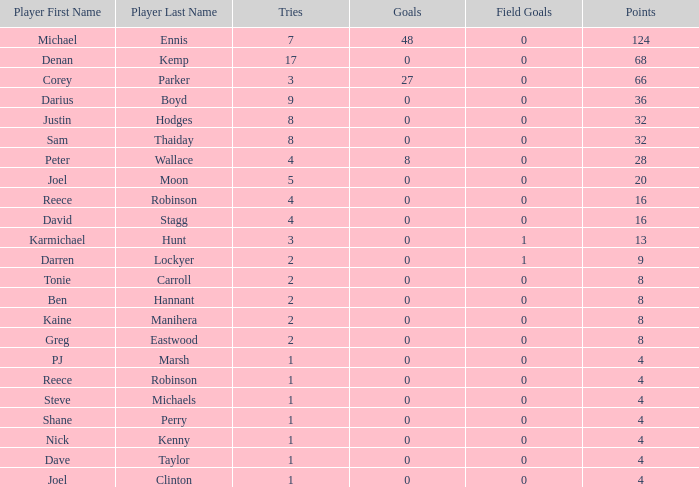What is the number of goals Dave Taylor, who has more than 1 tries, has? None. 